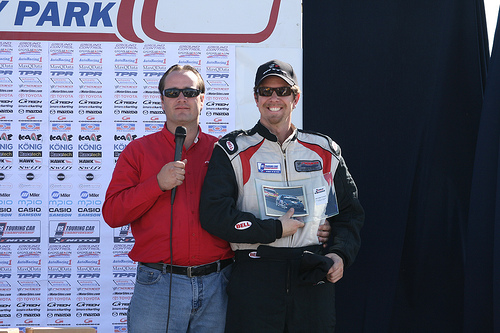<image>
Is there a trophy in front of the sign? Yes. The trophy is positioned in front of the sign, appearing closer to the camera viewpoint. 